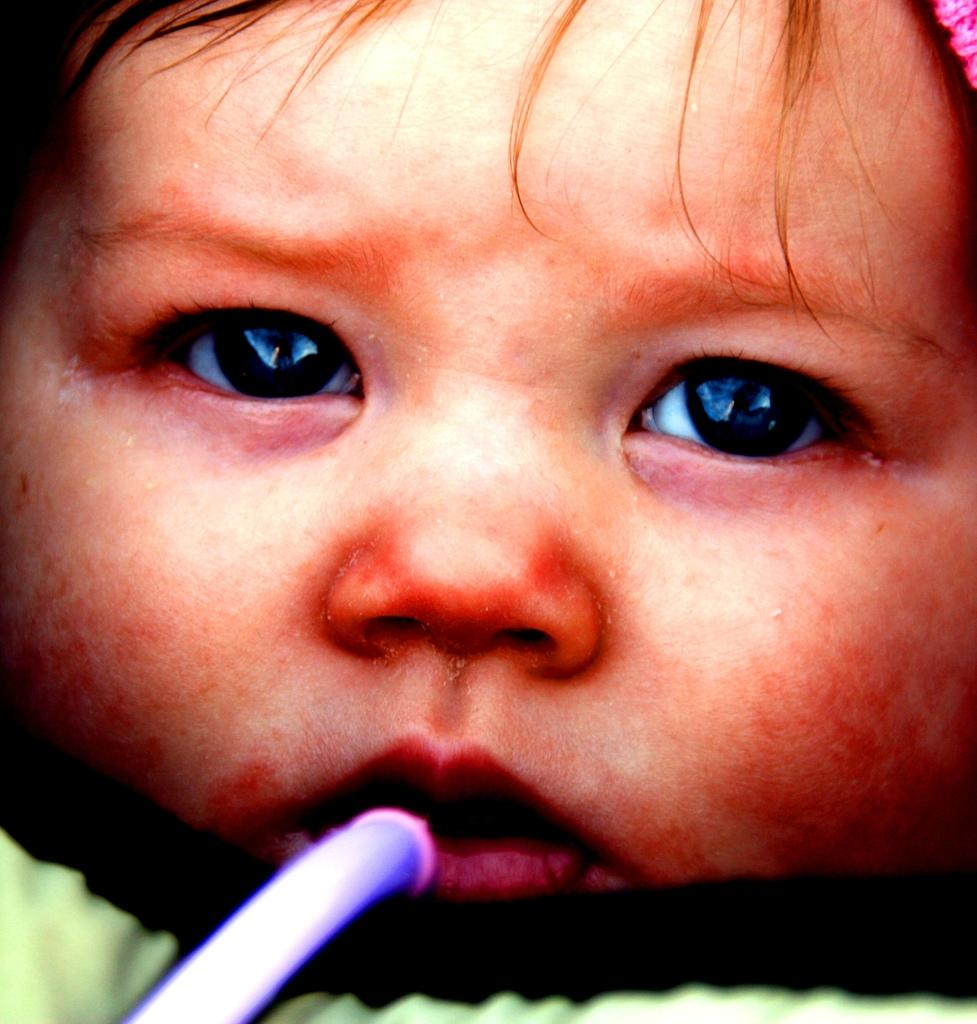What is the main subject of the image? The main subject of the image is a baby. What is the baby doing in the image? The baby has a straw in her mouth. What nation is depicted in the image? There is no nation depicted in the image; it features a baby with a straw in her mouth. Is there a bridge visible in the image? There is no bridge present in the image. 